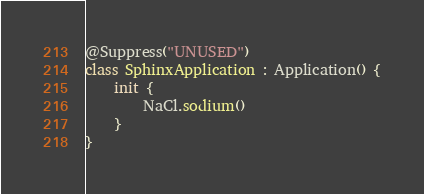Convert code to text. <code><loc_0><loc_0><loc_500><loc_500><_Kotlin_>
@Suppress("UNUSED")
class SphinxApplication : Application() {
    init {
        NaCl.sodium()
    }
}
</code> 